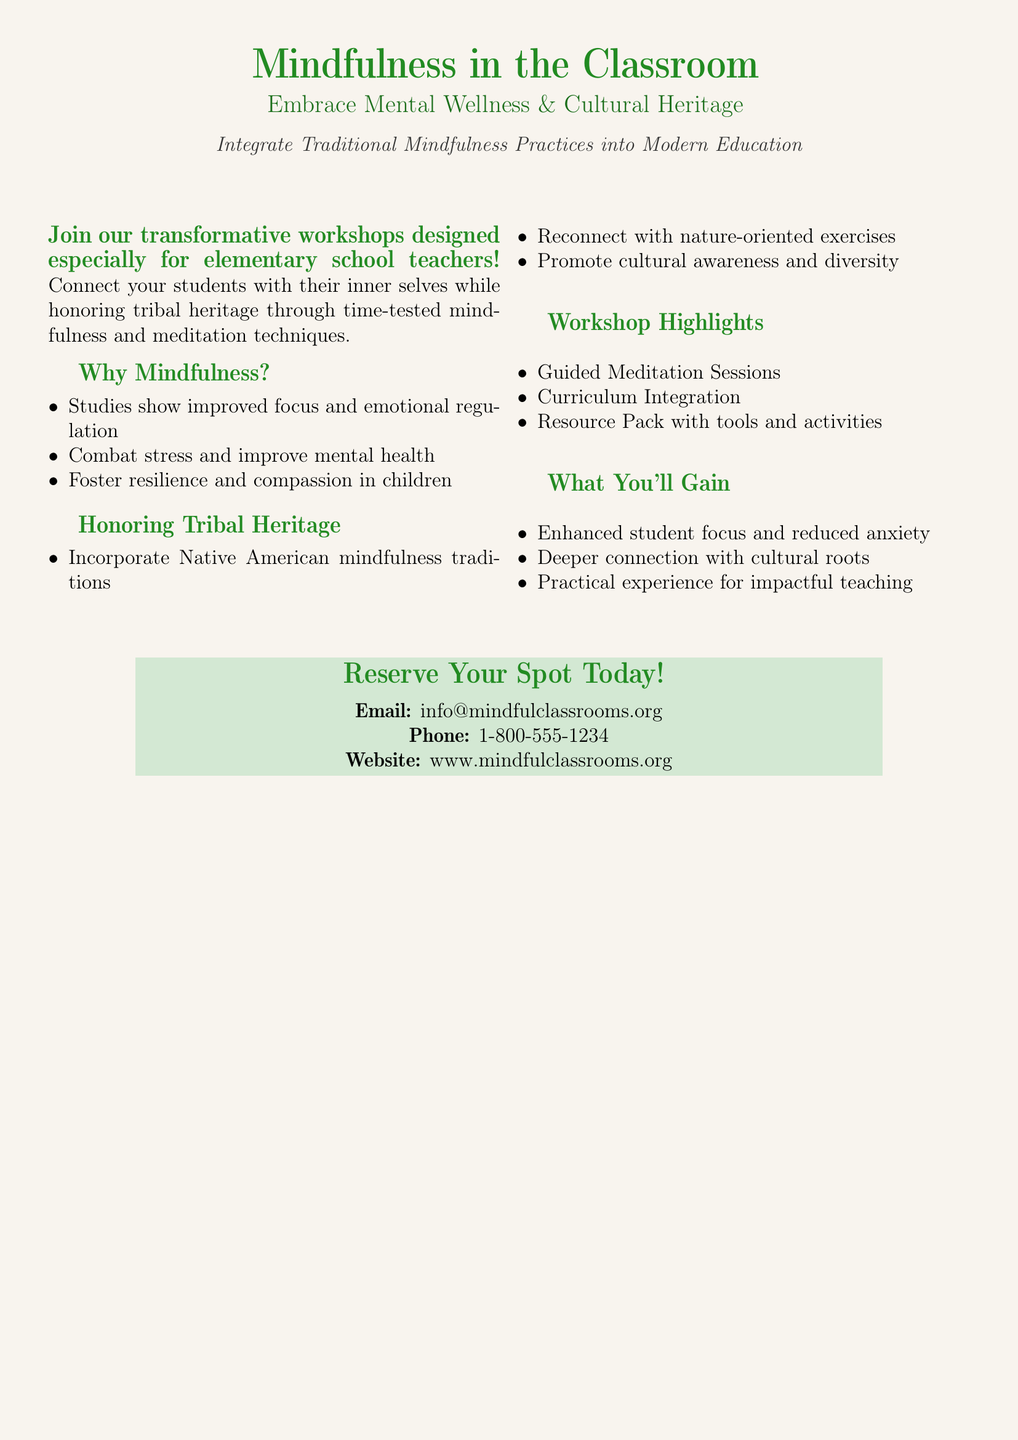What is the main focus of the workshops? The workshops are designed to integrate traditional mindfulness practices into modern education, emphasizing mental wellness and cultural heritage.
Answer: Mindfulness practices What is the email address for inquiries? The document provides contact information, specifically an email address for inquiries about the workshops.
Answer: info@mindfulclassrooms.org How can teachers benefit from these workshops? The document lists benefits such as enhanced student focus and reduced anxiety, reflecting the positive impacts of the workshops.
Answer: Enhanced student focus What is one highlight of the workshop? The advertisement mentions various highlights, one of which is guided meditation sessions offered during the workshops.
Answer: Guided Meditation Sessions What aspect of education do the workshops honor? The workshops specifically incorporate elements that connect with and honor tribal heritage through various practices.
Answer: Tribal Heritage How can participants reserve their spot? The document outlines how interested individuals may reserve their spot through the contact details provided.
Answer: Email or phone What are two expected outcomes from attending these workshops? The document indicates that participants will experience a deeper connection with cultural roots and practical experience for impactful teaching.
Answer: Connection with cultural roots What type of exercises are included in the workshops? The ad highlights that nature-oriented exercises are part of the workshop to promote cultural awareness and mindfulness.
Answer: Nature-oriented exercises What is the main color used in the advertisement? The advertisement prominently features a specific shade that is referred to throughout the document, enhancing the overall theme.
Answer: Nature green 